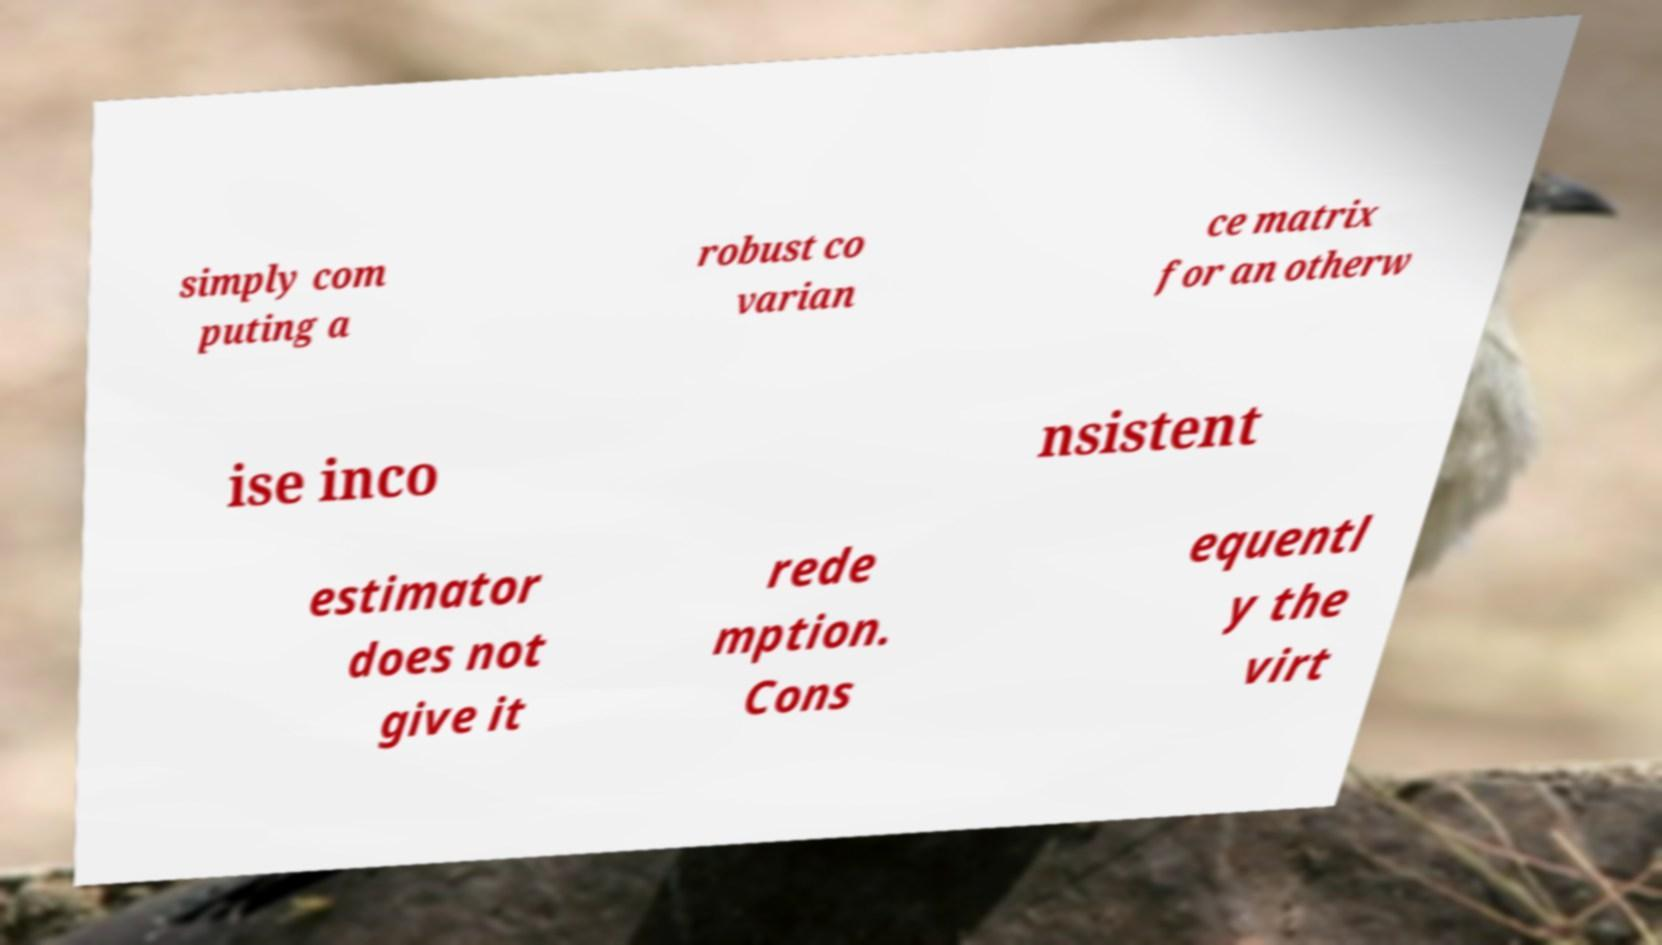Can you read and provide the text displayed in the image?This photo seems to have some interesting text. Can you extract and type it out for me? simply com puting a robust co varian ce matrix for an otherw ise inco nsistent estimator does not give it rede mption. Cons equentl y the virt 